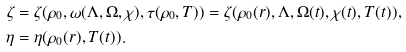Convert formula to latex. <formula><loc_0><loc_0><loc_500><loc_500>\zeta & = \zeta ( \rho _ { 0 } , \omega ( \Lambda , \Omega , \chi ) , \tau ( \rho _ { 0 } , T ) ) = \zeta ( \rho _ { 0 } ( r ) , \Lambda , \Omega ( t ) , \chi ( t ) , T ( t ) ) , \\ \eta & = \eta ( \rho _ { 0 } ( r ) , T ( t ) ) .</formula> 